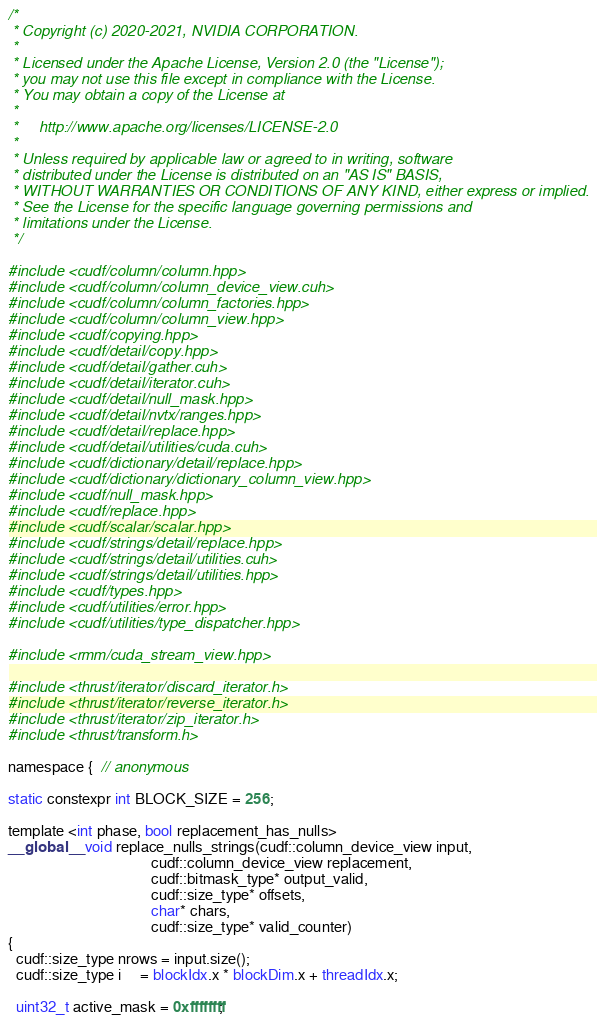<code> <loc_0><loc_0><loc_500><loc_500><_Cuda_>/*
 * Copyright (c) 2020-2021, NVIDIA CORPORATION.
 *
 * Licensed under the Apache License, Version 2.0 (the "License");
 * you may not use this file except in compliance with the License.
 * You may obtain a copy of the License at
 *
 *     http://www.apache.org/licenses/LICENSE-2.0
 *
 * Unless required by applicable law or agreed to in writing, software
 * distributed under the License is distributed on an "AS IS" BASIS,
 * WITHOUT WARRANTIES OR CONDITIONS OF ANY KIND, either express or implied.
 * See the License for the specific language governing permissions and
 * limitations under the License.
 */

#include <cudf/column/column.hpp>
#include <cudf/column/column_device_view.cuh>
#include <cudf/column/column_factories.hpp>
#include <cudf/column/column_view.hpp>
#include <cudf/copying.hpp>
#include <cudf/detail/copy.hpp>
#include <cudf/detail/gather.cuh>
#include <cudf/detail/iterator.cuh>
#include <cudf/detail/null_mask.hpp>
#include <cudf/detail/nvtx/ranges.hpp>
#include <cudf/detail/replace.hpp>
#include <cudf/detail/utilities/cuda.cuh>
#include <cudf/dictionary/detail/replace.hpp>
#include <cudf/dictionary/dictionary_column_view.hpp>
#include <cudf/null_mask.hpp>
#include <cudf/replace.hpp>
#include <cudf/scalar/scalar.hpp>
#include <cudf/strings/detail/replace.hpp>
#include <cudf/strings/detail/utilities.cuh>
#include <cudf/strings/detail/utilities.hpp>
#include <cudf/types.hpp>
#include <cudf/utilities/error.hpp>
#include <cudf/utilities/type_dispatcher.hpp>

#include <rmm/cuda_stream_view.hpp>

#include <thrust/iterator/discard_iterator.h>
#include <thrust/iterator/reverse_iterator.h>
#include <thrust/iterator/zip_iterator.h>
#include <thrust/transform.h>

namespace {  // anonymous

static constexpr int BLOCK_SIZE = 256;

template <int phase, bool replacement_has_nulls>
__global__ void replace_nulls_strings(cudf::column_device_view input,
                                      cudf::column_device_view replacement,
                                      cudf::bitmask_type* output_valid,
                                      cudf::size_type* offsets,
                                      char* chars,
                                      cudf::size_type* valid_counter)
{
  cudf::size_type nrows = input.size();
  cudf::size_type i     = blockIdx.x * blockDim.x + threadIdx.x;

  uint32_t active_mask = 0xffffffff;</code> 